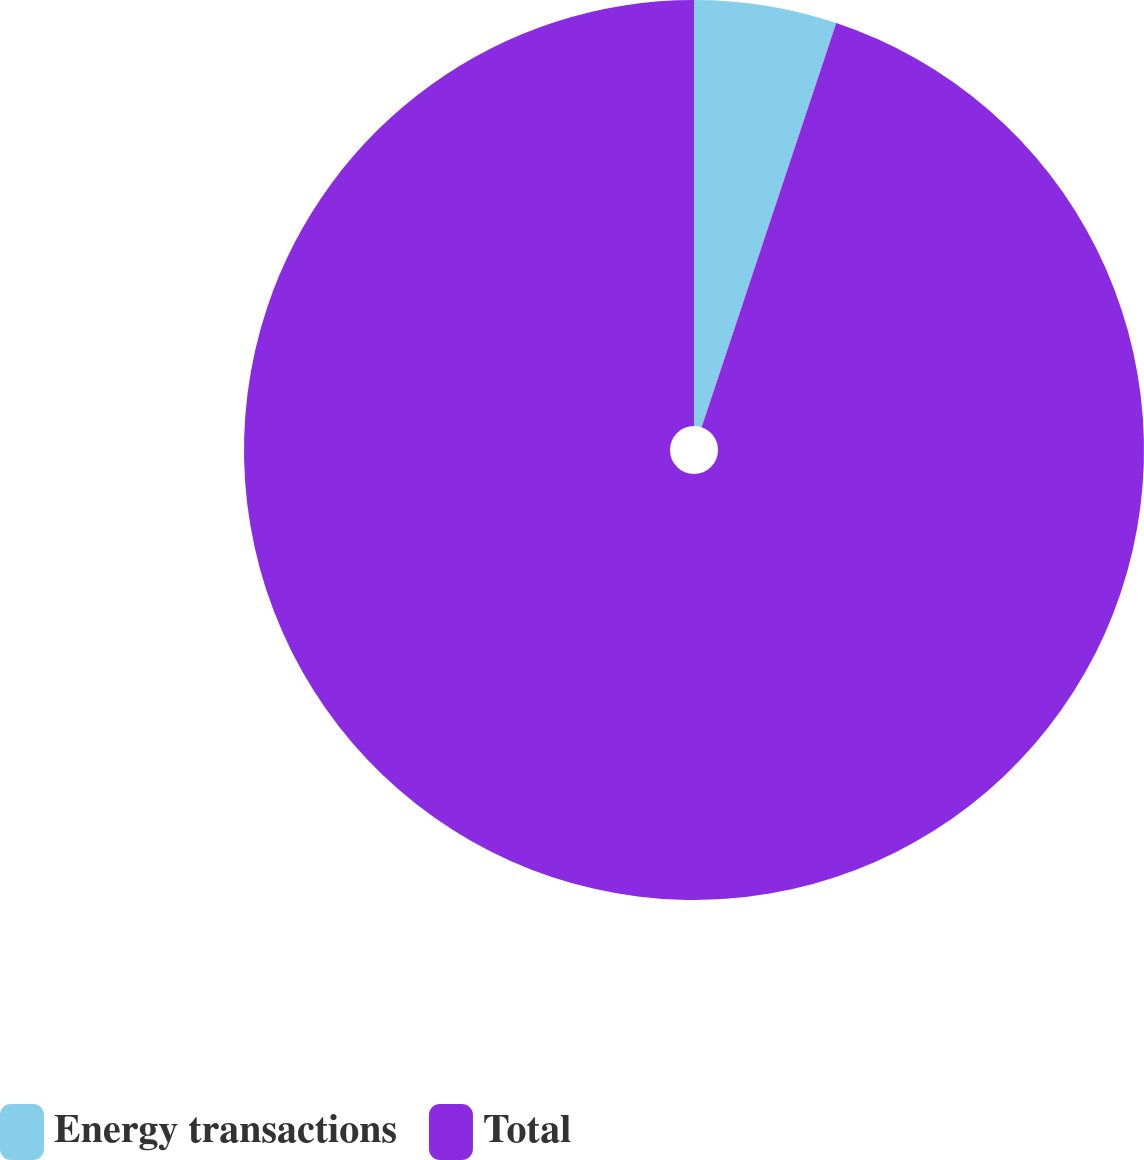<chart> <loc_0><loc_0><loc_500><loc_500><pie_chart><fcel>Energy transactions<fcel>Total<nl><fcel>5.12%<fcel>94.88%<nl></chart> 